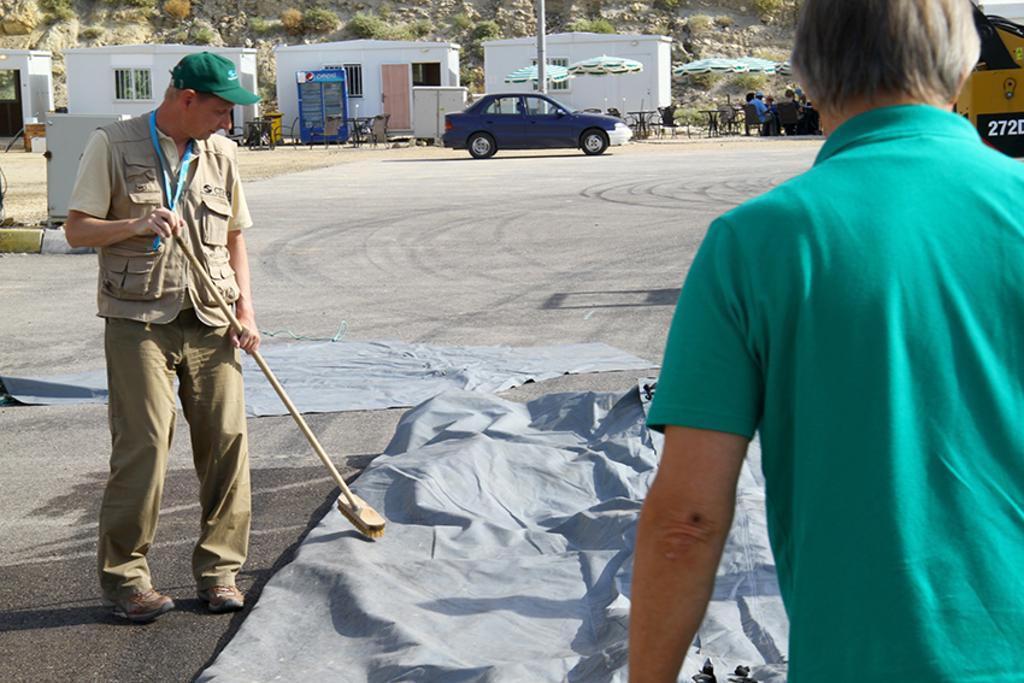How would you summarize this image in a sentence or two? In this picture there is a man who is wearing cap, jacket, shirt, trouser and shoe. He is holding a viper. He is standing near to the plastic covers. On the right there is another man who is wearing green t-shirt. In the back there is a car which is parked near to the pole. Beside that we can see the group of persons were sitting on the chair near to the table. In the background we can see house, doors, windows, fridge, table, chairs, umbrella and grass. At the top there is a mountain. 